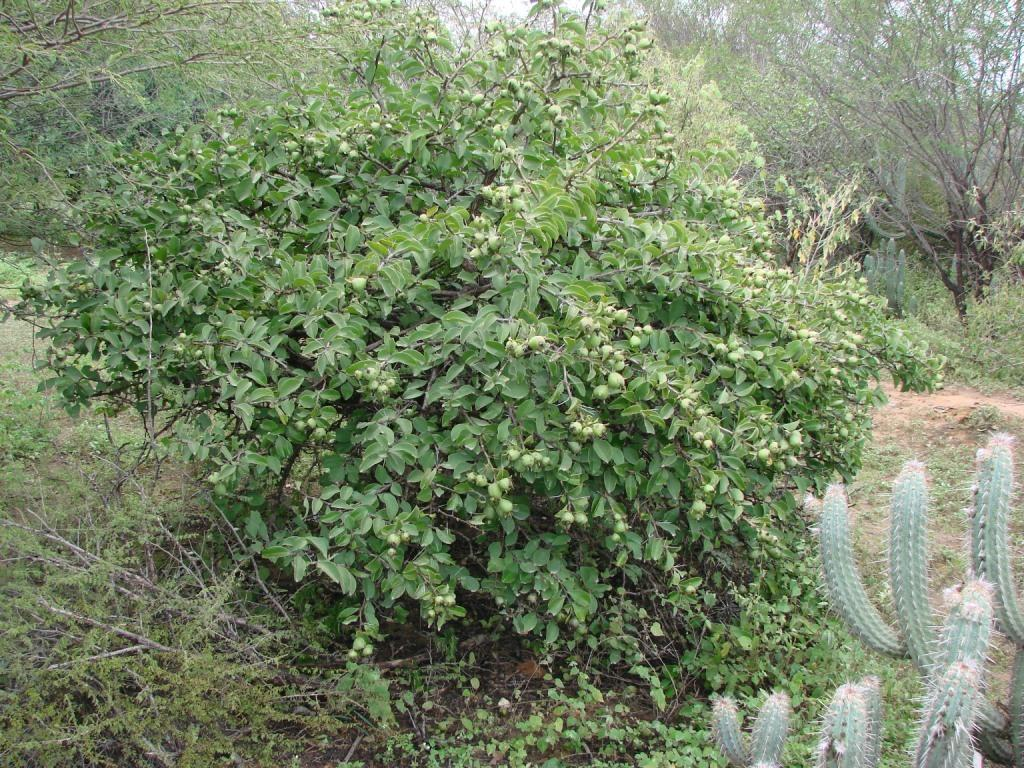What type of plant is in the image with fruits? There is a tree with fruits in the image. What other type of plant can be seen in the image? There is a cactus plant in the image. How many trees are visible in the image besides the one with fruits? There are many other trees in the image. What time does the town start in the image? There is no town present in the image, so it is not possible to determine when it starts. Is there a turkey visible in the image? There is no turkey present in the image. 